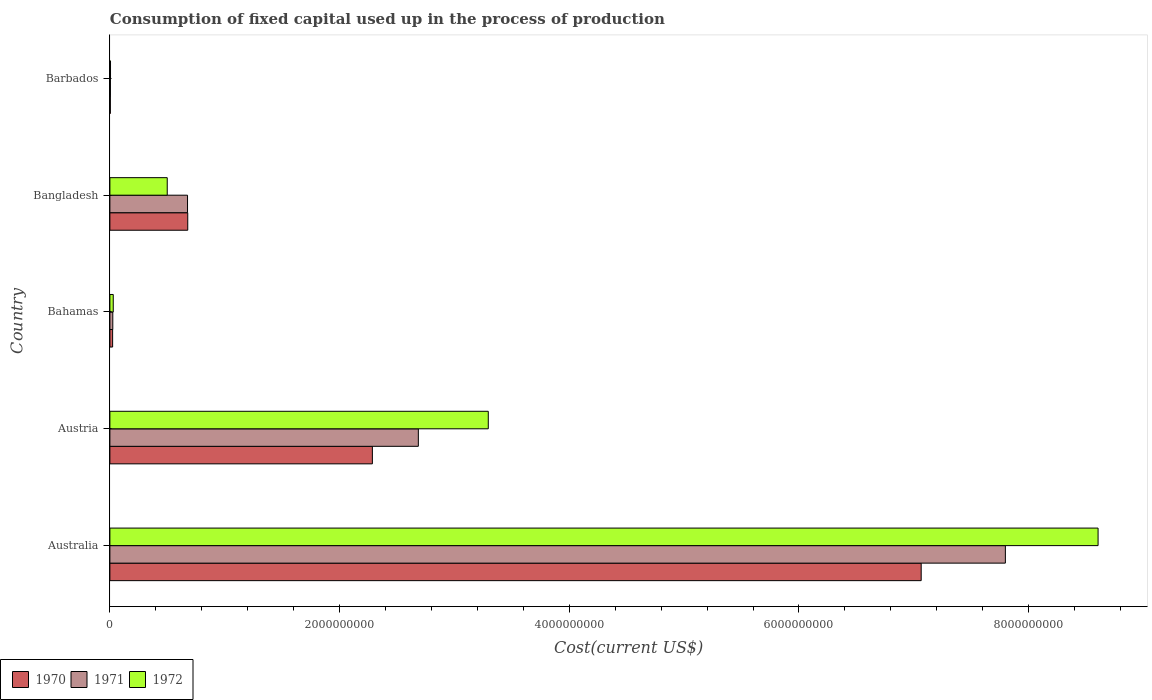How many different coloured bars are there?
Make the answer very short. 3. How many groups of bars are there?
Offer a very short reply. 5. Are the number of bars per tick equal to the number of legend labels?
Make the answer very short. Yes. Are the number of bars on each tick of the Y-axis equal?
Your answer should be compact. Yes. What is the amount consumed in the process of production in 1970 in Bahamas?
Your answer should be compact. 2.39e+07. Across all countries, what is the maximum amount consumed in the process of production in 1971?
Keep it short and to the point. 7.80e+09. Across all countries, what is the minimum amount consumed in the process of production in 1972?
Your response must be concise. 5.43e+06. In which country was the amount consumed in the process of production in 1972 minimum?
Provide a short and direct response. Barbados. What is the total amount consumed in the process of production in 1970 in the graph?
Your answer should be very brief. 1.01e+1. What is the difference between the amount consumed in the process of production in 1971 in Bahamas and that in Barbados?
Keep it short and to the point. 2.08e+07. What is the difference between the amount consumed in the process of production in 1970 in Australia and the amount consumed in the process of production in 1972 in Austria?
Make the answer very short. 3.77e+09. What is the average amount consumed in the process of production in 1972 per country?
Your response must be concise. 2.49e+09. What is the difference between the amount consumed in the process of production in 1972 and amount consumed in the process of production in 1971 in Bahamas?
Keep it short and to the point. 3.86e+06. What is the ratio of the amount consumed in the process of production in 1970 in Austria to that in Bangladesh?
Give a very brief answer. 3.37. Is the amount consumed in the process of production in 1972 in Australia less than that in Austria?
Provide a succinct answer. No. What is the difference between the highest and the second highest amount consumed in the process of production in 1971?
Offer a terse response. 5.11e+09. What is the difference between the highest and the lowest amount consumed in the process of production in 1971?
Your response must be concise. 7.79e+09. Is the sum of the amount consumed in the process of production in 1972 in Bangladesh and Barbados greater than the maximum amount consumed in the process of production in 1971 across all countries?
Offer a very short reply. No. What does the 2nd bar from the top in Bangladesh represents?
Keep it short and to the point. 1971. What does the 3rd bar from the bottom in Bahamas represents?
Keep it short and to the point. 1972. Is it the case that in every country, the sum of the amount consumed in the process of production in 1970 and amount consumed in the process of production in 1971 is greater than the amount consumed in the process of production in 1972?
Ensure brevity in your answer.  Yes. How many bars are there?
Make the answer very short. 15. Where does the legend appear in the graph?
Provide a succinct answer. Bottom left. What is the title of the graph?
Offer a very short reply. Consumption of fixed capital used up in the process of production. What is the label or title of the X-axis?
Give a very brief answer. Cost(current US$). What is the Cost(current US$) in 1970 in Australia?
Keep it short and to the point. 7.06e+09. What is the Cost(current US$) in 1971 in Australia?
Make the answer very short. 7.80e+09. What is the Cost(current US$) of 1972 in Australia?
Your answer should be compact. 8.60e+09. What is the Cost(current US$) of 1970 in Austria?
Your answer should be compact. 2.29e+09. What is the Cost(current US$) in 1971 in Austria?
Keep it short and to the point. 2.69e+09. What is the Cost(current US$) of 1972 in Austria?
Keep it short and to the point. 3.29e+09. What is the Cost(current US$) of 1970 in Bahamas?
Your answer should be very brief. 2.39e+07. What is the Cost(current US$) of 1971 in Bahamas?
Provide a succinct answer. 2.53e+07. What is the Cost(current US$) of 1972 in Bahamas?
Your answer should be compact. 2.92e+07. What is the Cost(current US$) in 1970 in Bangladesh?
Offer a very short reply. 6.78e+08. What is the Cost(current US$) in 1971 in Bangladesh?
Keep it short and to the point. 6.76e+08. What is the Cost(current US$) in 1972 in Bangladesh?
Provide a short and direct response. 4.99e+08. What is the Cost(current US$) of 1970 in Barbados?
Ensure brevity in your answer.  3.84e+06. What is the Cost(current US$) in 1971 in Barbados?
Your response must be concise. 4.52e+06. What is the Cost(current US$) of 1972 in Barbados?
Your answer should be very brief. 5.43e+06. Across all countries, what is the maximum Cost(current US$) of 1970?
Provide a short and direct response. 7.06e+09. Across all countries, what is the maximum Cost(current US$) in 1971?
Your answer should be very brief. 7.80e+09. Across all countries, what is the maximum Cost(current US$) of 1972?
Keep it short and to the point. 8.60e+09. Across all countries, what is the minimum Cost(current US$) of 1970?
Keep it short and to the point. 3.84e+06. Across all countries, what is the minimum Cost(current US$) of 1971?
Make the answer very short. 4.52e+06. Across all countries, what is the minimum Cost(current US$) in 1972?
Offer a terse response. 5.43e+06. What is the total Cost(current US$) of 1970 in the graph?
Offer a terse response. 1.01e+1. What is the total Cost(current US$) of 1971 in the graph?
Your response must be concise. 1.12e+1. What is the total Cost(current US$) of 1972 in the graph?
Your response must be concise. 1.24e+1. What is the difference between the Cost(current US$) of 1970 in Australia and that in Austria?
Make the answer very short. 4.78e+09. What is the difference between the Cost(current US$) of 1971 in Australia and that in Austria?
Your answer should be compact. 5.11e+09. What is the difference between the Cost(current US$) of 1972 in Australia and that in Austria?
Keep it short and to the point. 5.31e+09. What is the difference between the Cost(current US$) in 1970 in Australia and that in Bahamas?
Your response must be concise. 7.04e+09. What is the difference between the Cost(current US$) in 1971 in Australia and that in Bahamas?
Keep it short and to the point. 7.77e+09. What is the difference between the Cost(current US$) in 1972 in Australia and that in Bahamas?
Ensure brevity in your answer.  8.58e+09. What is the difference between the Cost(current US$) of 1970 in Australia and that in Bangladesh?
Ensure brevity in your answer.  6.39e+09. What is the difference between the Cost(current US$) of 1971 in Australia and that in Bangladesh?
Your answer should be very brief. 7.12e+09. What is the difference between the Cost(current US$) in 1972 in Australia and that in Bangladesh?
Give a very brief answer. 8.11e+09. What is the difference between the Cost(current US$) in 1970 in Australia and that in Barbados?
Your answer should be compact. 7.06e+09. What is the difference between the Cost(current US$) of 1971 in Australia and that in Barbados?
Your response must be concise. 7.79e+09. What is the difference between the Cost(current US$) of 1972 in Australia and that in Barbados?
Your answer should be very brief. 8.60e+09. What is the difference between the Cost(current US$) in 1970 in Austria and that in Bahamas?
Offer a very short reply. 2.26e+09. What is the difference between the Cost(current US$) in 1971 in Austria and that in Bahamas?
Ensure brevity in your answer.  2.66e+09. What is the difference between the Cost(current US$) of 1972 in Austria and that in Bahamas?
Provide a succinct answer. 3.27e+09. What is the difference between the Cost(current US$) of 1970 in Austria and that in Bangladesh?
Offer a very short reply. 1.61e+09. What is the difference between the Cost(current US$) in 1971 in Austria and that in Bangladesh?
Provide a short and direct response. 2.01e+09. What is the difference between the Cost(current US$) in 1972 in Austria and that in Bangladesh?
Offer a very short reply. 2.80e+09. What is the difference between the Cost(current US$) of 1970 in Austria and that in Barbados?
Provide a short and direct response. 2.28e+09. What is the difference between the Cost(current US$) of 1971 in Austria and that in Barbados?
Give a very brief answer. 2.68e+09. What is the difference between the Cost(current US$) of 1972 in Austria and that in Barbados?
Provide a succinct answer. 3.29e+09. What is the difference between the Cost(current US$) in 1970 in Bahamas and that in Bangladesh?
Ensure brevity in your answer.  -6.54e+08. What is the difference between the Cost(current US$) in 1971 in Bahamas and that in Bangladesh?
Your answer should be compact. -6.51e+08. What is the difference between the Cost(current US$) in 1972 in Bahamas and that in Bangladesh?
Keep it short and to the point. -4.70e+08. What is the difference between the Cost(current US$) of 1970 in Bahamas and that in Barbados?
Provide a short and direct response. 2.00e+07. What is the difference between the Cost(current US$) in 1971 in Bahamas and that in Barbados?
Provide a short and direct response. 2.08e+07. What is the difference between the Cost(current US$) of 1972 in Bahamas and that in Barbados?
Keep it short and to the point. 2.38e+07. What is the difference between the Cost(current US$) in 1970 in Bangladesh and that in Barbados?
Your answer should be very brief. 6.74e+08. What is the difference between the Cost(current US$) in 1971 in Bangladesh and that in Barbados?
Make the answer very short. 6.72e+08. What is the difference between the Cost(current US$) in 1972 in Bangladesh and that in Barbados?
Your answer should be compact. 4.94e+08. What is the difference between the Cost(current US$) of 1970 in Australia and the Cost(current US$) of 1971 in Austria?
Your response must be concise. 4.38e+09. What is the difference between the Cost(current US$) in 1970 in Australia and the Cost(current US$) in 1972 in Austria?
Offer a very short reply. 3.77e+09. What is the difference between the Cost(current US$) in 1971 in Australia and the Cost(current US$) in 1972 in Austria?
Provide a short and direct response. 4.50e+09. What is the difference between the Cost(current US$) of 1970 in Australia and the Cost(current US$) of 1971 in Bahamas?
Your answer should be compact. 7.04e+09. What is the difference between the Cost(current US$) of 1970 in Australia and the Cost(current US$) of 1972 in Bahamas?
Ensure brevity in your answer.  7.03e+09. What is the difference between the Cost(current US$) of 1971 in Australia and the Cost(current US$) of 1972 in Bahamas?
Provide a succinct answer. 7.77e+09. What is the difference between the Cost(current US$) of 1970 in Australia and the Cost(current US$) of 1971 in Bangladesh?
Keep it short and to the point. 6.39e+09. What is the difference between the Cost(current US$) of 1970 in Australia and the Cost(current US$) of 1972 in Bangladesh?
Your answer should be compact. 6.56e+09. What is the difference between the Cost(current US$) of 1971 in Australia and the Cost(current US$) of 1972 in Bangladesh?
Provide a short and direct response. 7.30e+09. What is the difference between the Cost(current US$) of 1970 in Australia and the Cost(current US$) of 1971 in Barbados?
Offer a terse response. 7.06e+09. What is the difference between the Cost(current US$) in 1970 in Australia and the Cost(current US$) in 1972 in Barbados?
Provide a succinct answer. 7.06e+09. What is the difference between the Cost(current US$) in 1971 in Australia and the Cost(current US$) in 1972 in Barbados?
Your answer should be compact. 7.79e+09. What is the difference between the Cost(current US$) of 1970 in Austria and the Cost(current US$) of 1971 in Bahamas?
Provide a succinct answer. 2.26e+09. What is the difference between the Cost(current US$) in 1970 in Austria and the Cost(current US$) in 1972 in Bahamas?
Keep it short and to the point. 2.26e+09. What is the difference between the Cost(current US$) of 1971 in Austria and the Cost(current US$) of 1972 in Bahamas?
Make the answer very short. 2.66e+09. What is the difference between the Cost(current US$) in 1970 in Austria and the Cost(current US$) in 1971 in Bangladesh?
Your response must be concise. 1.61e+09. What is the difference between the Cost(current US$) of 1970 in Austria and the Cost(current US$) of 1972 in Bangladesh?
Offer a very short reply. 1.79e+09. What is the difference between the Cost(current US$) in 1971 in Austria and the Cost(current US$) in 1972 in Bangladesh?
Offer a very short reply. 2.19e+09. What is the difference between the Cost(current US$) in 1970 in Austria and the Cost(current US$) in 1971 in Barbados?
Offer a terse response. 2.28e+09. What is the difference between the Cost(current US$) in 1970 in Austria and the Cost(current US$) in 1972 in Barbados?
Your response must be concise. 2.28e+09. What is the difference between the Cost(current US$) of 1971 in Austria and the Cost(current US$) of 1972 in Barbados?
Provide a short and direct response. 2.68e+09. What is the difference between the Cost(current US$) in 1970 in Bahamas and the Cost(current US$) in 1971 in Bangladesh?
Give a very brief answer. -6.52e+08. What is the difference between the Cost(current US$) in 1970 in Bahamas and the Cost(current US$) in 1972 in Bangladesh?
Your answer should be very brief. -4.75e+08. What is the difference between the Cost(current US$) in 1971 in Bahamas and the Cost(current US$) in 1972 in Bangladesh?
Your answer should be very brief. -4.74e+08. What is the difference between the Cost(current US$) of 1970 in Bahamas and the Cost(current US$) of 1971 in Barbados?
Your answer should be very brief. 1.93e+07. What is the difference between the Cost(current US$) in 1970 in Bahamas and the Cost(current US$) in 1972 in Barbados?
Provide a short and direct response. 1.84e+07. What is the difference between the Cost(current US$) of 1971 in Bahamas and the Cost(current US$) of 1972 in Barbados?
Make the answer very short. 1.99e+07. What is the difference between the Cost(current US$) in 1970 in Bangladesh and the Cost(current US$) in 1971 in Barbados?
Offer a terse response. 6.73e+08. What is the difference between the Cost(current US$) in 1970 in Bangladesh and the Cost(current US$) in 1972 in Barbados?
Offer a very short reply. 6.73e+08. What is the difference between the Cost(current US$) in 1971 in Bangladesh and the Cost(current US$) in 1972 in Barbados?
Your answer should be compact. 6.71e+08. What is the average Cost(current US$) in 1970 per country?
Make the answer very short. 2.01e+09. What is the average Cost(current US$) of 1971 per country?
Give a very brief answer. 2.24e+09. What is the average Cost(current US$) in 1972 per country?
Your answer should be compact. 2.49e+09. What is the difference between the Cost(current US$) in 1970 and Cost(current US$) in 1971 in Australia?
Provide a succinct answer. -7.33e+08. What is the difference between the Cost(current US$) in 1970 and Cost(current US$) in 1972 in Australia?
Provide a succinct answer. -1.54e+09. What is the difference between the Cost(current US$) of 1971 and Cost(current US$) of 1972 in Australia?
Your response must be concise. -8.07e+08. What is the difference between the Cost(current US$) in 1970 and Cost(current US$) in 1971 in Austria?
Keep it short and to the point. -4.00e+08. What is the difference between the Cost(current US$) in 1970 and Cost(current US$) in 1972 in Austria?
Give a very brief answer. -1.01e+09. What is the difference between the Cost(current US$) in 1971 and Cost(current US$) in 1972 in Austria?
Ensure brevity in your answer.  -6.09e+08. What is the difference between the Cost(current US$) of 1970 and Cost(current US$) of 1971 in Bahamas?
Offer a terse response. -1.50e+06. What is the difference between the Cost(current US$) of 1970 and Cost(current US$) of 1972 in Bahamas?
Make the answer very short. -5.35e+06. What is the difference between the Cost(current US$) of 1971 and Cost(current US$) of 1972 in Bahamas?
Your answer should be very brief. -3.86e+06. What is the difference between the Cost(current US$) in 1970 and Cost(current US$) in 1971 in Bangladesh?
Ensure brevity in your answer.  1.86e+06. What is the difference between the Cost(current US$) in 1970 and Cost(current US$) in 1972 in Bangladesh?
Ensure brevity in your answer.  1.79e+08. What is the difference between the Cost(current US$) of 1971 and Cost(current US$) of 1972 in Bangladesh?
Make the answer very short. 1.77e+08. What is the difference between the Cost(current US$) in 1970 and Cost(current US$) in 1971 in Barbados?
Provide a succinct answer. -6.77e+05. What is the difference between the Cost(current US$) in 1970 and Cost(current US$) in 1972 in Barbados?
Your answer should be very brief. -1.58e+06. What is the difference between the Cost(current US$) in 1971 and Cost(current US$) in 1972 in Barbados?
Give a very brief answer. -9.05e+05. What is the ratio of the Cost(current US$) of 1970 in Australia to that in Austria?
Give a very brief answer. 3.09. What is the ratio of the Cost(current US$) in 1971 in Australia to that in Austria?
Your response must be concise. 2.9. What is the ratio of the Cost(current US$) in 1972 in Australia to that in Austria?
Provide a short and direct response. 2.61. What is the ratio of the Cost(current US$) in 1970 in Australia to that in Bahamas?
Offer a terse response. 296.18. What is the ratio of the Cost(current US$) of 1971 in Australia to that in Bahamas?
Give a very brief answer. 307.59. What is the ratio of the Cost(current US$) of 1972 in Australia to that in Bahamas?
Keep it short and to the point. 294.62. What is the ratio of the Cost(current US$) in 1970 in Australia to that in Bangladesh?
Provide a short and direct response. 10.42. What is the ratio of the Cost(current US$) of 1971 in Australia to that in Bangladesh?
Ensure brevity in your answer.  11.53. What is the ratio of the Cost(current US$) of 1972 in Australia to that in Bangladesh?
Your answer should be very brief. 17.23. What is the ratio of the Cost(current US$) of 1970 in Australia to that in Barbados?
Ensure brevity in your answer.  1837.93. What is the ratio of the Cost(current US$) in 1971 in Australia to that in Barbados?
Offer a terse response. 1724.72. What is the ratio of the Cost(current US$) in 1972 in Australia to that in Barbados?
Provide a short and direct response. 1585.76. What is the ratio of the Cost(current US$) in 1970 in Austria to that in Bahamas?
Make the answer very short. 95.83. What is the ratio of the Cost(current US$) of 1971 in Austria to that in Bahamas?
Your response must be concise. 105.95. What is the ratio of the Cost(current US$) of 1972 in Austria to that in Bahamas?
Ensure brevity in your answer.  112.81. What is the ratio of the Cost(current US$) of 1970 in Austria to that in Bangladesh?
Give a very brief answer. 3.37. What is the ratio of the Cost(current US$) of 1971 in Austria to that in Bangladesh?
Ensure brevity in your answer.  3.97. What is the ratio of the Cost(current US$) of 1972 in Austria to that in Bangladesh?
Give a very brief answer. 6.6. What is the ratio of the Cost(current US$) of 1970 in Austria to that in Barbados?
Offer a terse response. 594.65. What is the ratio of the Cost(current US$) in 1971 in Austria to that in Barbados?
Keep it short and to the point. 594.1. What is the ratio of the Cost(current US$) of 1972 in Austria to that in Barbados?
Offer a terse response. 607.2. What is the ratio of the Cost(current US$) of 1970 in Bahamas to that in Bangladesh?
Your answer should be compact. 0.04. What is the ratio of the Cost(current US$) of 1971 in Bahamas to that in Bangladesh?
Ensure brevity in your answer.  0.04. What is the ratio of the Cost(current US$) in 1972 in Bahamas to that in Bangladesh?
Offer a terse response. 0.06. What is the ratio of the Cost(current US$) in 1970 in Bahamas to that in Barbados?
Make the answer very short. 6.21. What is the ratio of the Cost(current US$) in 1971 in Bahamas to that in Barbados?
Ensure brevity in your answer.  5.61. What is the ratio of the Cost(current US$) of 1972 in Bahamas to that in Barbados?
Offer a very short reply. 5.38. What is the ratio of the Cost(current US$) in 1970 in Bangladesh to that in Barbados?
Offer a terse response. 176.39. What is the ratio of the Cost(current US$) of 1971 in Bangladesh to that in Barbados?
Give a very brief answer. 149.55. What is the ratio of the Cost(current US$) in 1972 in Bangladesh to that in Barbados?
Provide a succinct answer. 92.02. What is the difference between the highest and the second highest Cost(current US$) in 1970?
Offer a very short reply. 4.78e+09. What is the difference between the highest and the second highest Cost(current US$) in 1971?
Your response must be concise. 5.11e+09. What is the difference between the highest and the second highest Cost(current US$) in 1972?
Your answer should be compact. 5.31e+09. What is the difference between the highest and the lowest Cost(current US$) of 1970?
Your answer should be very brief. 7.06e+09. What is the difference between the highest and the lowest Cost(current US$) in 1971?
Provide a short and direct response. 7.79e+09. What is the difference between the highest and the lowest Cost(current US$) in 1972?
Provide a succinct answer. 8.60e+09. 